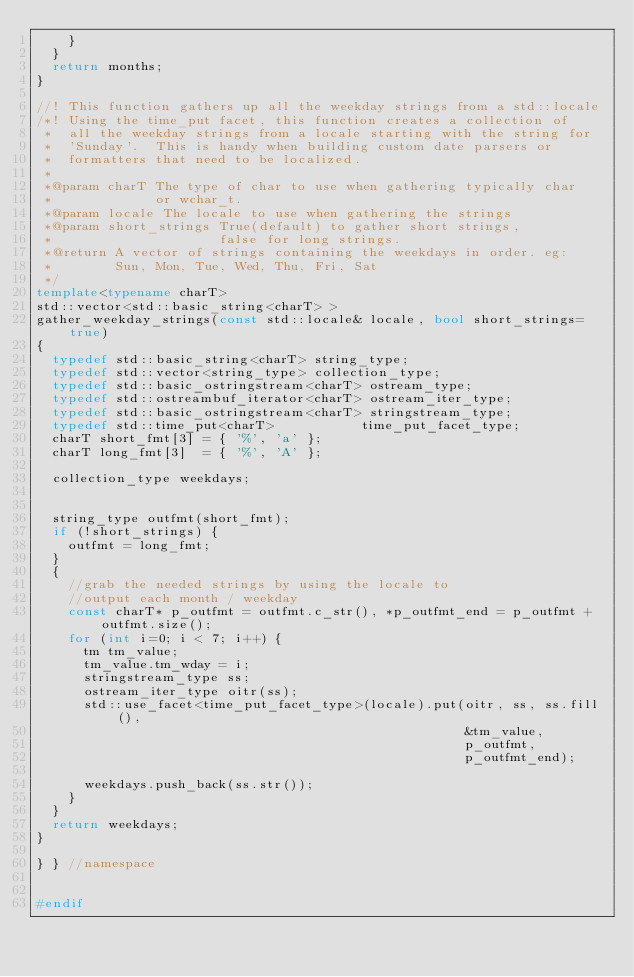<code> <loc_0><loc_0><loc_500><loc_500><_C++_>    }
  }
  return months;
}

//! This function gathers up all the weekday strings from a std::locale
/*! Using the time_put facet, this function creates a collection of
 *  all the weekday strings from a locale starting with the string for
 *  'Sunday'.  This is handy when building custom date parsers or
 *  formatters that need to be localized.
 *
 *@param charT The type of char to use when gathering typically char
 *             or wchar_t.
 *@param locale The locale to use when gathering the strings
 *@param short_strings True(default) to gather short strings,
 *                     false for long strings.
 *@return A vector of strings containing the weekdays in order. eg:
 *        Sun, Mon, Tue, Wed, Thu, Fri, Sat
 */
template<typename charT>
std::vector<std::basic_string<charT> >
gather_weekday_strings(const std::locale& locale, bool short_strings=true)
{
  typedef std::basic_string<charT> string_type;
  typedef std::vector<string_type> collection_type;
  typedef std::basic_ostringstream<charT> ostream_type;
  typedef std::ostreambuf_iterator<charT> ostream_iter_type;
  typedef std::basic_ostringstream<charT> stringstream_type;
  typedef std::time_put<charT>           time_put_facet_type;
  charT short_fmt[3] = { '%', 'a' };
  charT long_fmt[3]  = { '%', 'A' };

  collection_type weekdays;


  string_type outfmt(short_fmt);
  if (!short_strings) {
    outfmt = long_fmt;
  }
  {
    //grab the needed strings by using the locale to
    //output each month / weekday
    const charT* p_outfmt = outfmt.c_str(), *p_outfmt_end = p_outfmt + outfmt.size();
    for (int i=0; i < 7; i++) {
      tm tm_value;
      tm_value.tm_wday = i;
      stringstream_type ss;
      ostream_iter_type oitr(ss);
      std::use_facet<time_put_facet_type>(locale).put(oitr, ss, ss.fill(),
                                                      &tm_value,
                                                      p_outfmt,
                                                      p_outfmt_end);

      weekdays.push_back(ss.str());
    }
  }
  return weekdays;
}

} } //namespace


#endif
</code> 